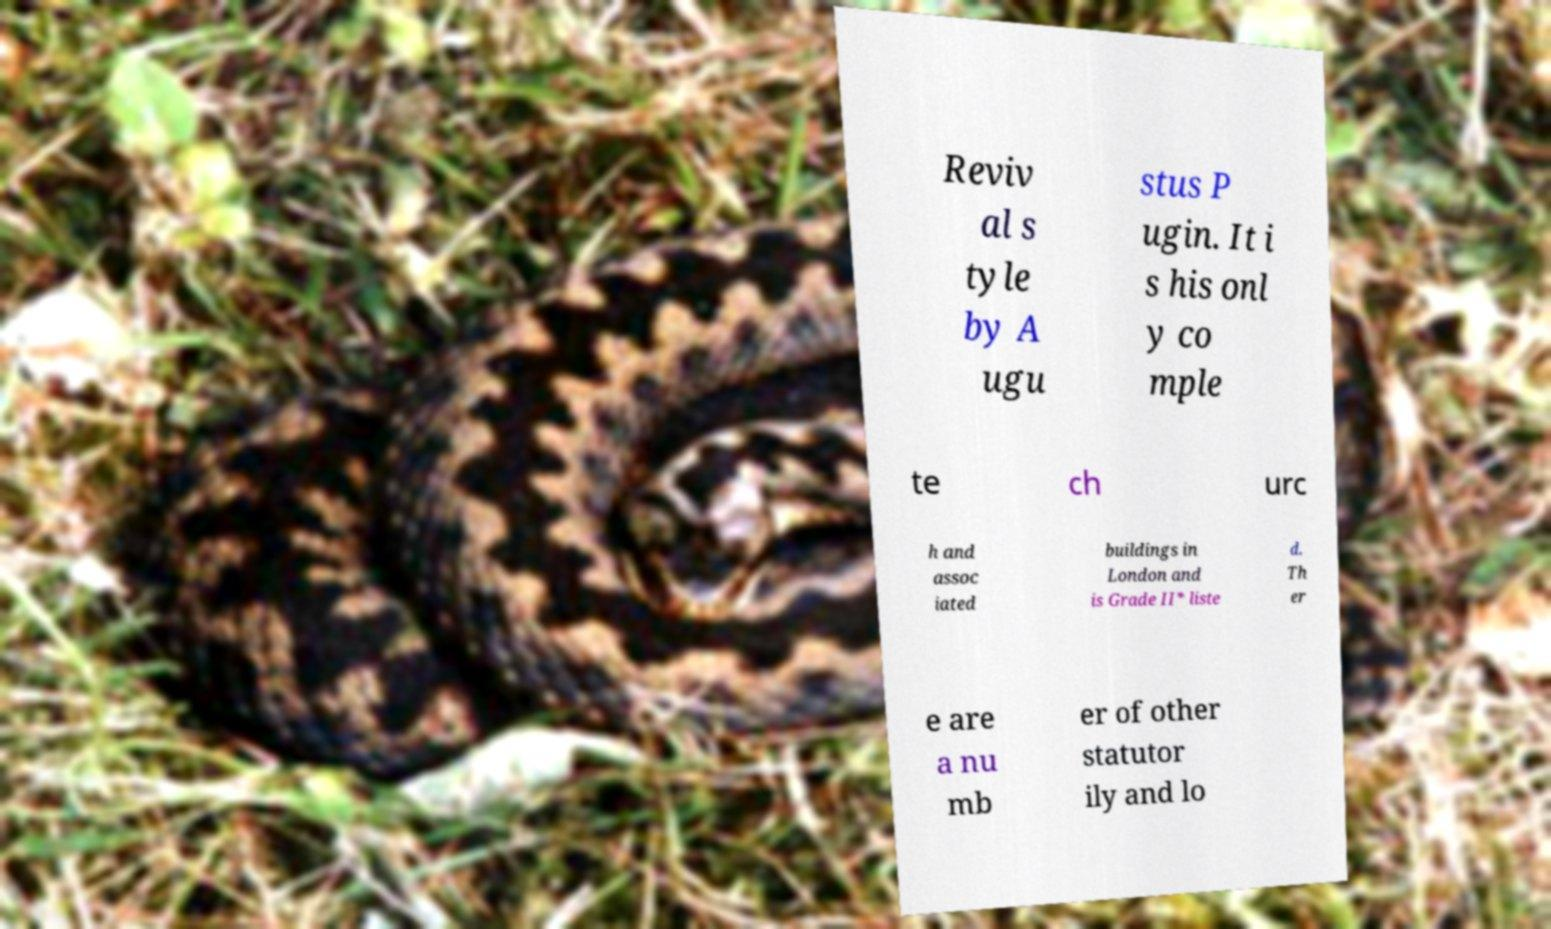Could you extract and type out the text from this image? Reviv al s tyle by A ugu stus P ugin. It i s his onl y co mple te ch urc h and assoc iated buildings in London and is Grade II* liste d. Th er e are a nu mb er of other statutor ily and lo 